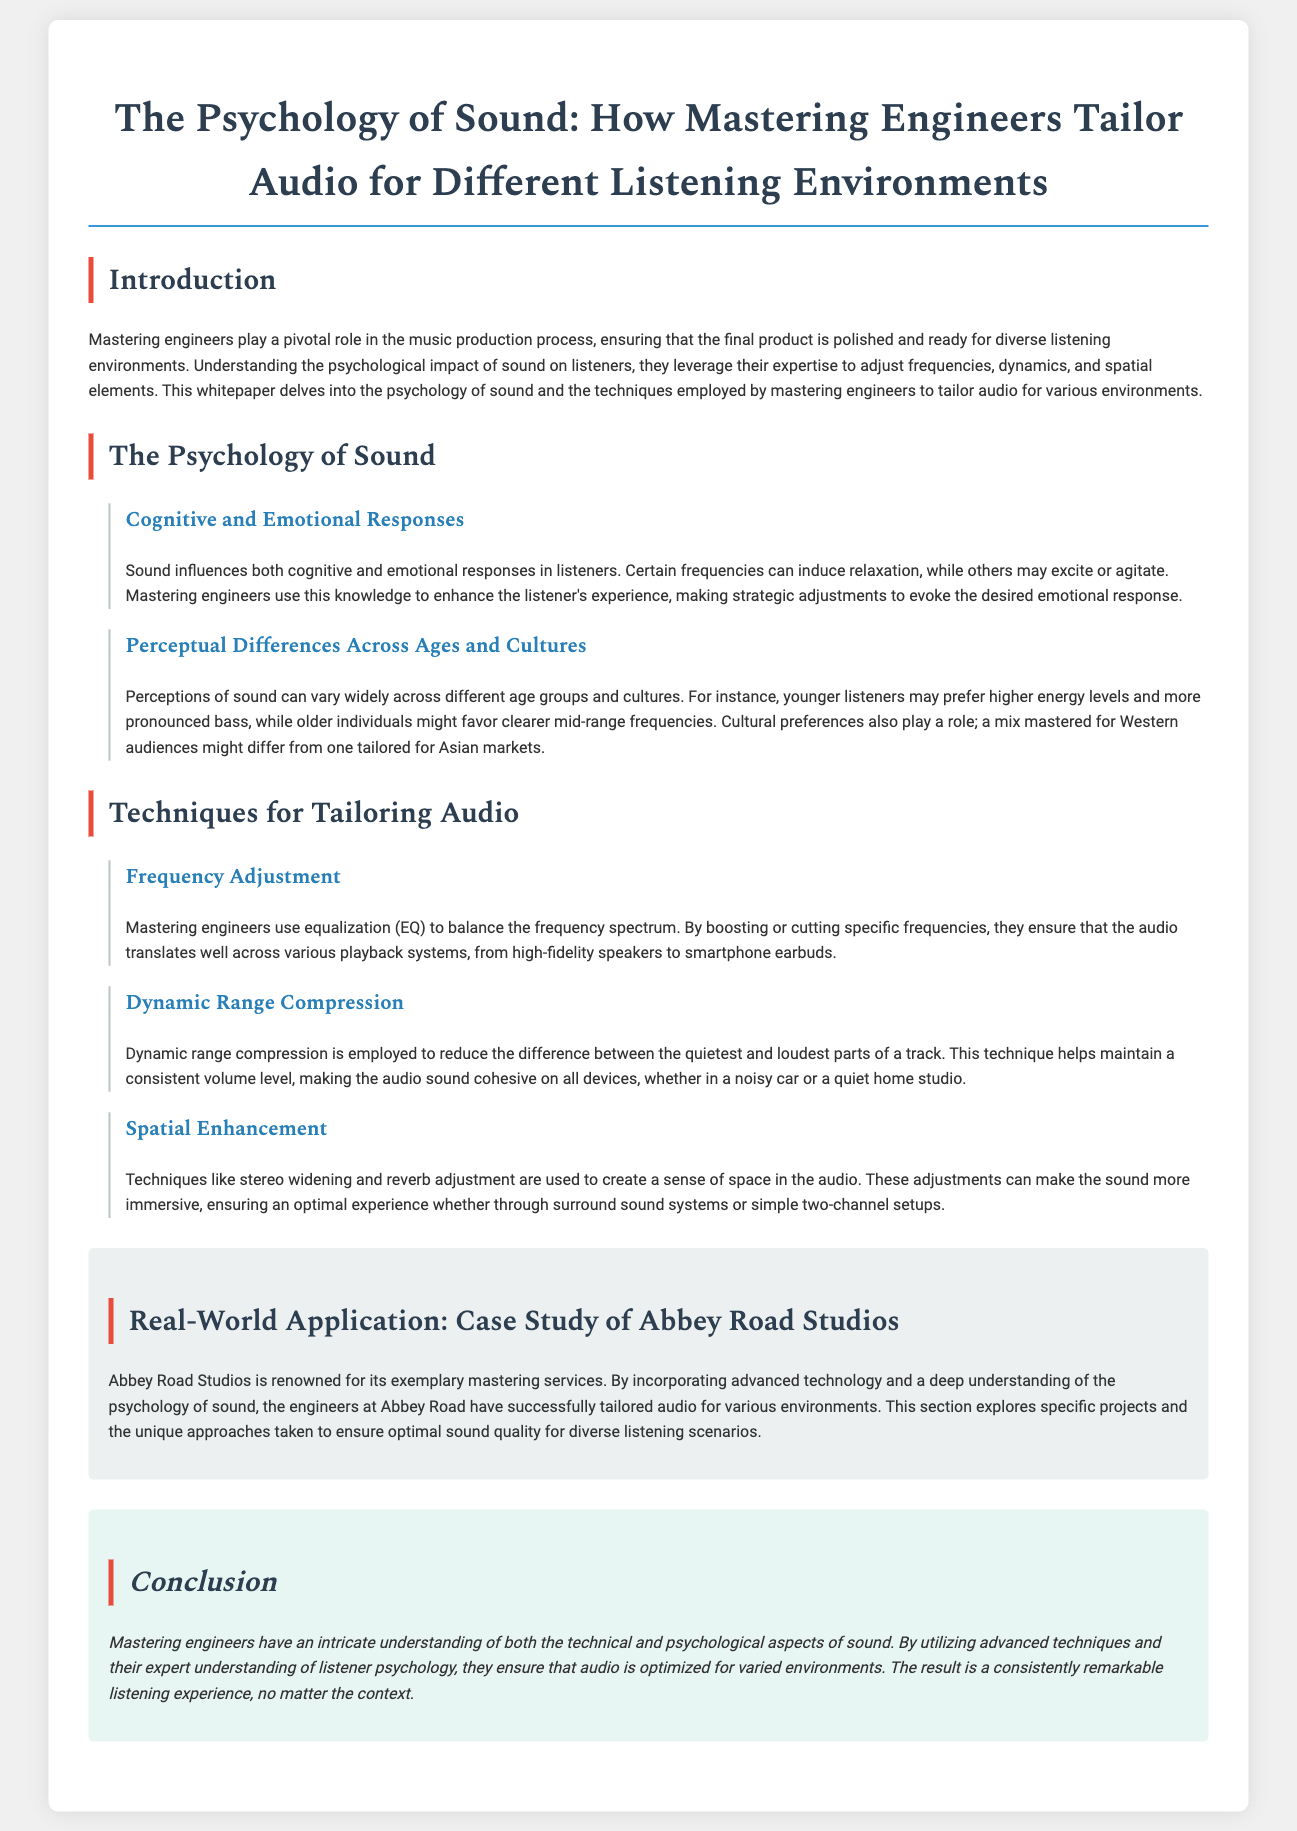What is the title of the whitepaper? The title summarizes the focus of the document, highlighting the relationship between psychology and audio mastering techniques.
Answer: The Psychology of Sound: How Mastering Engineers Tailor Audio for Different Listening Environments What role do mastering engineers play? The document states that mastering engineers ensure the final product is polished for diverse listening environments.
Answer: Pivotal role What technique is used to balance the frequency spectrum? The document mentions a specific method used by mastering engineers to adjust audio frequencies for clarity across different playback devices.
Answer: Equalization (EQ) How does sound influence listeners? This aspect is covered in the section discussing cognitive and emotional responses to sound.
Answer: Cognitive and emotional responses Which studio is highlighted as a case study in the document? The specific studio used as an example to illustrate practical applications of mastering techniques is mentioned.
Answer: Abbey Road Studios What is the purpose of dynamic range compression? The document outlines the objective of this technique within the mastering process.
Answer: Reduce difference between quietest and loudest parts What are the three techniques for tailoring audio mentioned? The document describes specific methods utilized by mastering engineers, which include frequency adjustment, dynamic range compression, and spatial enhancement.
Answer: Frequency adjustment, dynamic range compression, spatial enhancement What is the conclusion about mastering engineers' understanding? The summary reveals the comprehensive expertise that mastering engineers possess regarding audio and its psychology.
Answer: Intricate understanding What can certain frequencies induce? The document explains the emotional impact that different frequencies can have on listeners.
Answer: Relaxation 